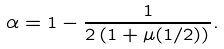Convert formula to latex. <formula><loc_0><loc_0><loc_500><loc_500>\alpha = 1 - \frac { 1 } { 2 \left ( 1 + \mu ( 1 / 2 ) \right ) } .</formula> 